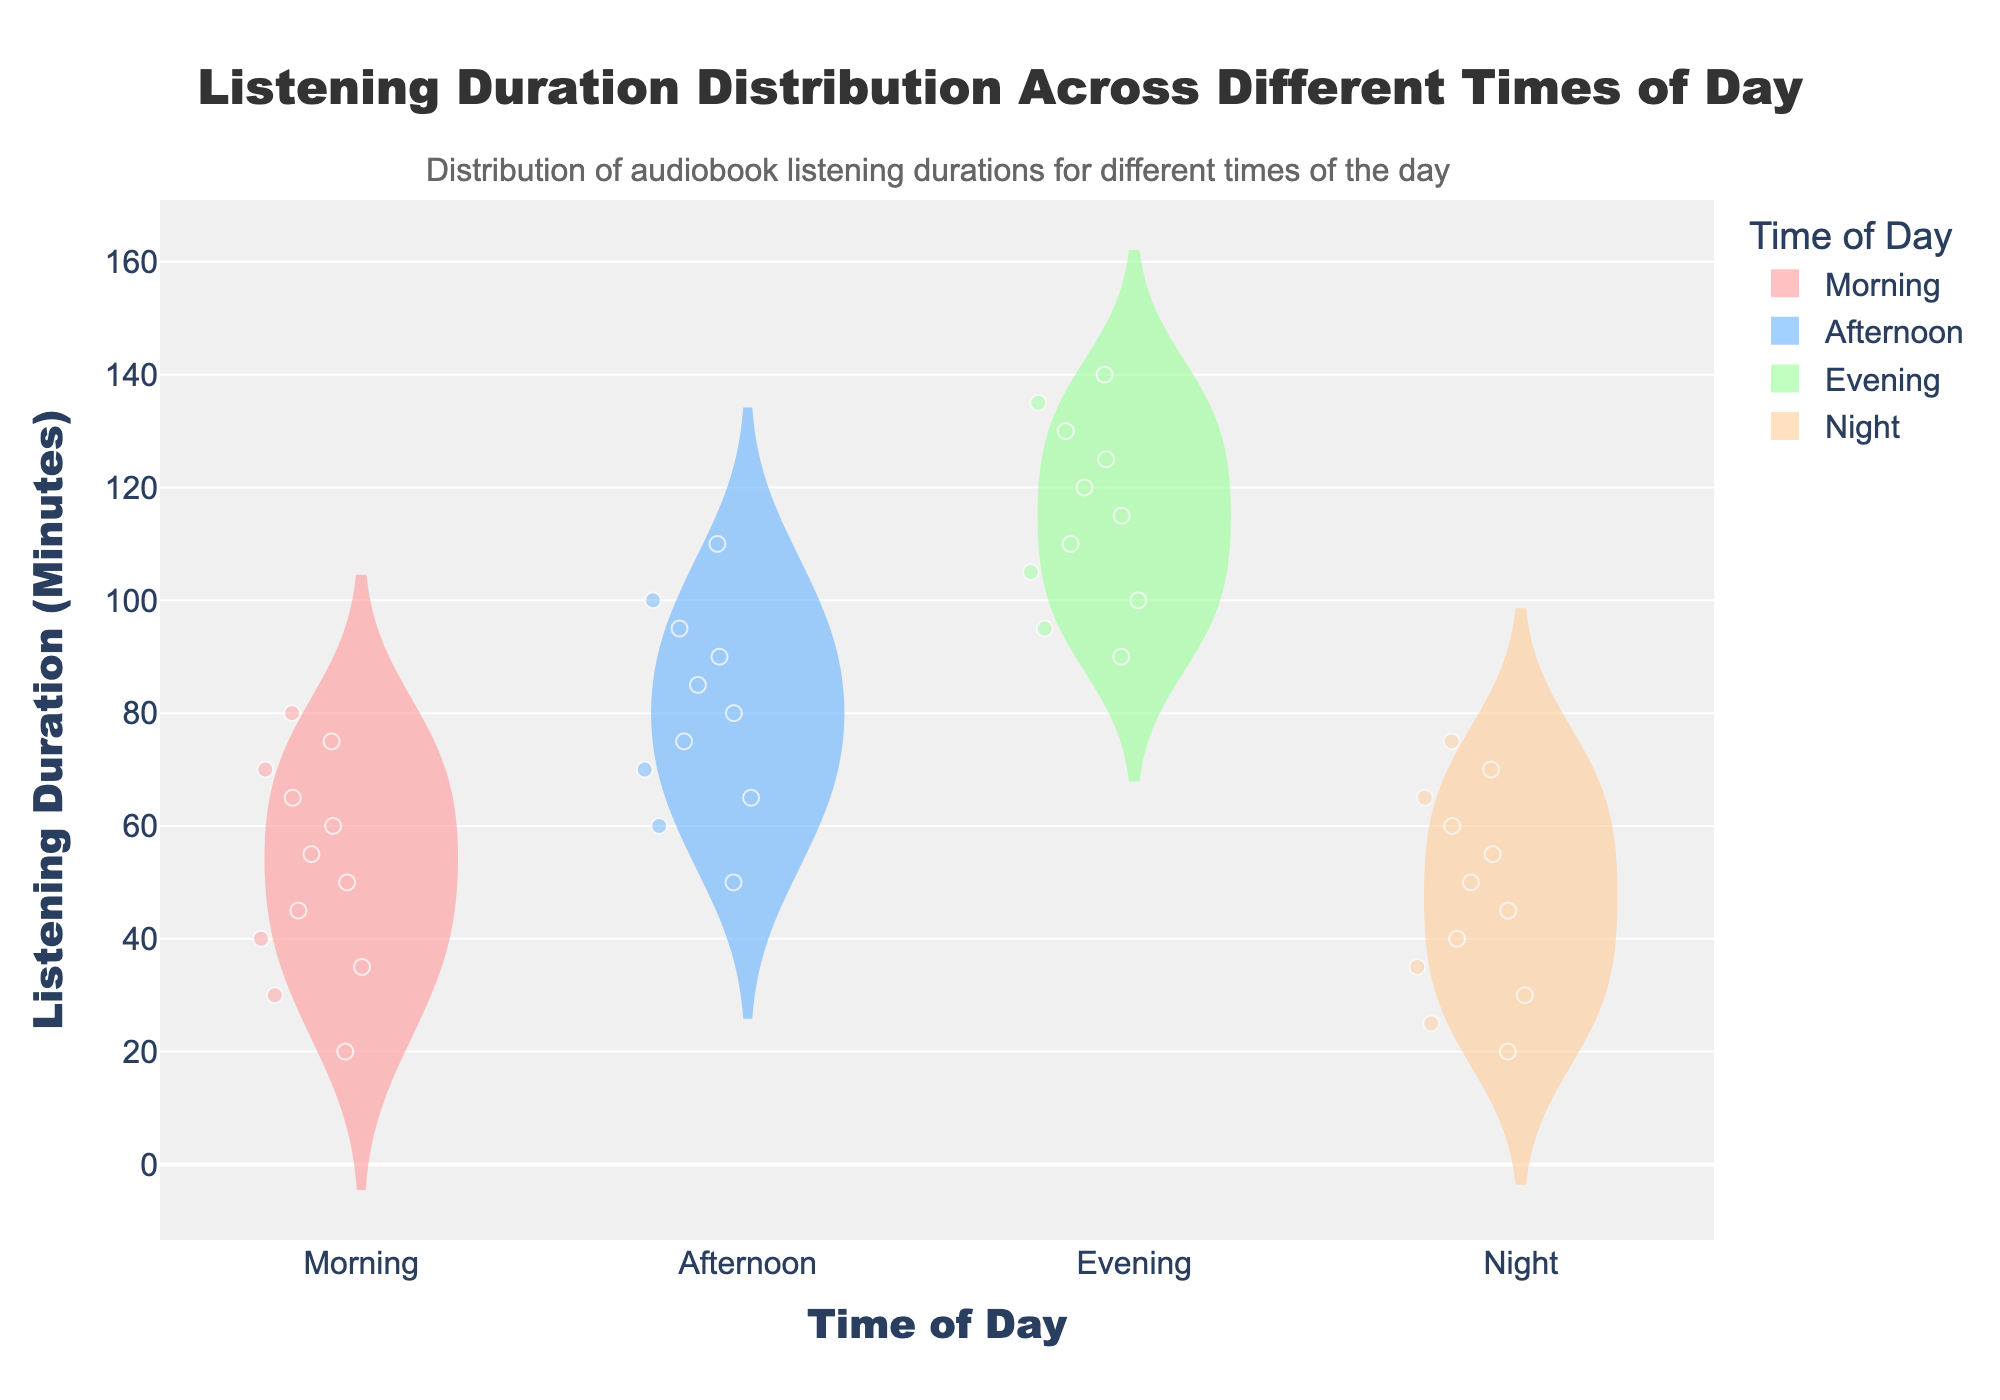What's the title of the figure? The title is usually located at the top of the figure, and it is clearly mentioned in the data and code provided.
Answer: Listening Duration Distribution Across Different Times of Day Which time of day has the longest listening duration? By examining the violin plots, we observe that the evening displays the highest maximum values on the y-axis.
Answer: Evening How many data points are represented for the morning listening duration? The number of data points can be counted directly from the data provided for the morning. There are 12 data points listed.
Answer: 12 Which time of day has the widest spread in listening duration? The spread or variability in listening duration is shown by the width of the violin plot. The evening has a wider spread compared to other times of the day.
Answer: Evening What is the mean listening duration for the afternoon? The mean value for the afternoon can be deduced by looking at the horizontal line in the violin plot representing the mean.
Answer: Around 80 minutes Which time of day has the smallest variability in listening duration? Variability or spread is represented by the width of the violin plot. The morning has a narrower plot compared to others, indicating low variability.
Answer: Morning Compare the maximum listening durations between afternoon and night. Which one is higher? The maximum value for the afternoon is around 110 minutes, while for the night, it is around 75 minutes. Therefore, afternoon has a higher maximum listening duration.
Answer: Afternoon What is the interquartile range (IQR) for the evening listening duration? The IQR is the range between the 25th and 75th percentiles within the box of the box plot visible within the violin plot. For evening, this range is roughly from 100 to 130 minutes.
Answer: Around 30 minutes Compare the median listening durations for morning and night. Which is higher? The median is shown by the central line within the box of the box plot inside the violin plots. The morning's median is around 55 minutes, and the night’s median is about 45 minutes. Hence, morning is higher.
Answer: Morning Calculate the average listening duration for night and compare it to the morning average. What’s the difference? By summing up the night (660) and morning (680) listening minutes and dividing them by their respective counts (12 for morning, 12 for night), we get the average. The difference is then calculated: 55 (morning) - 45 (night) = 10.
Answer: 10 